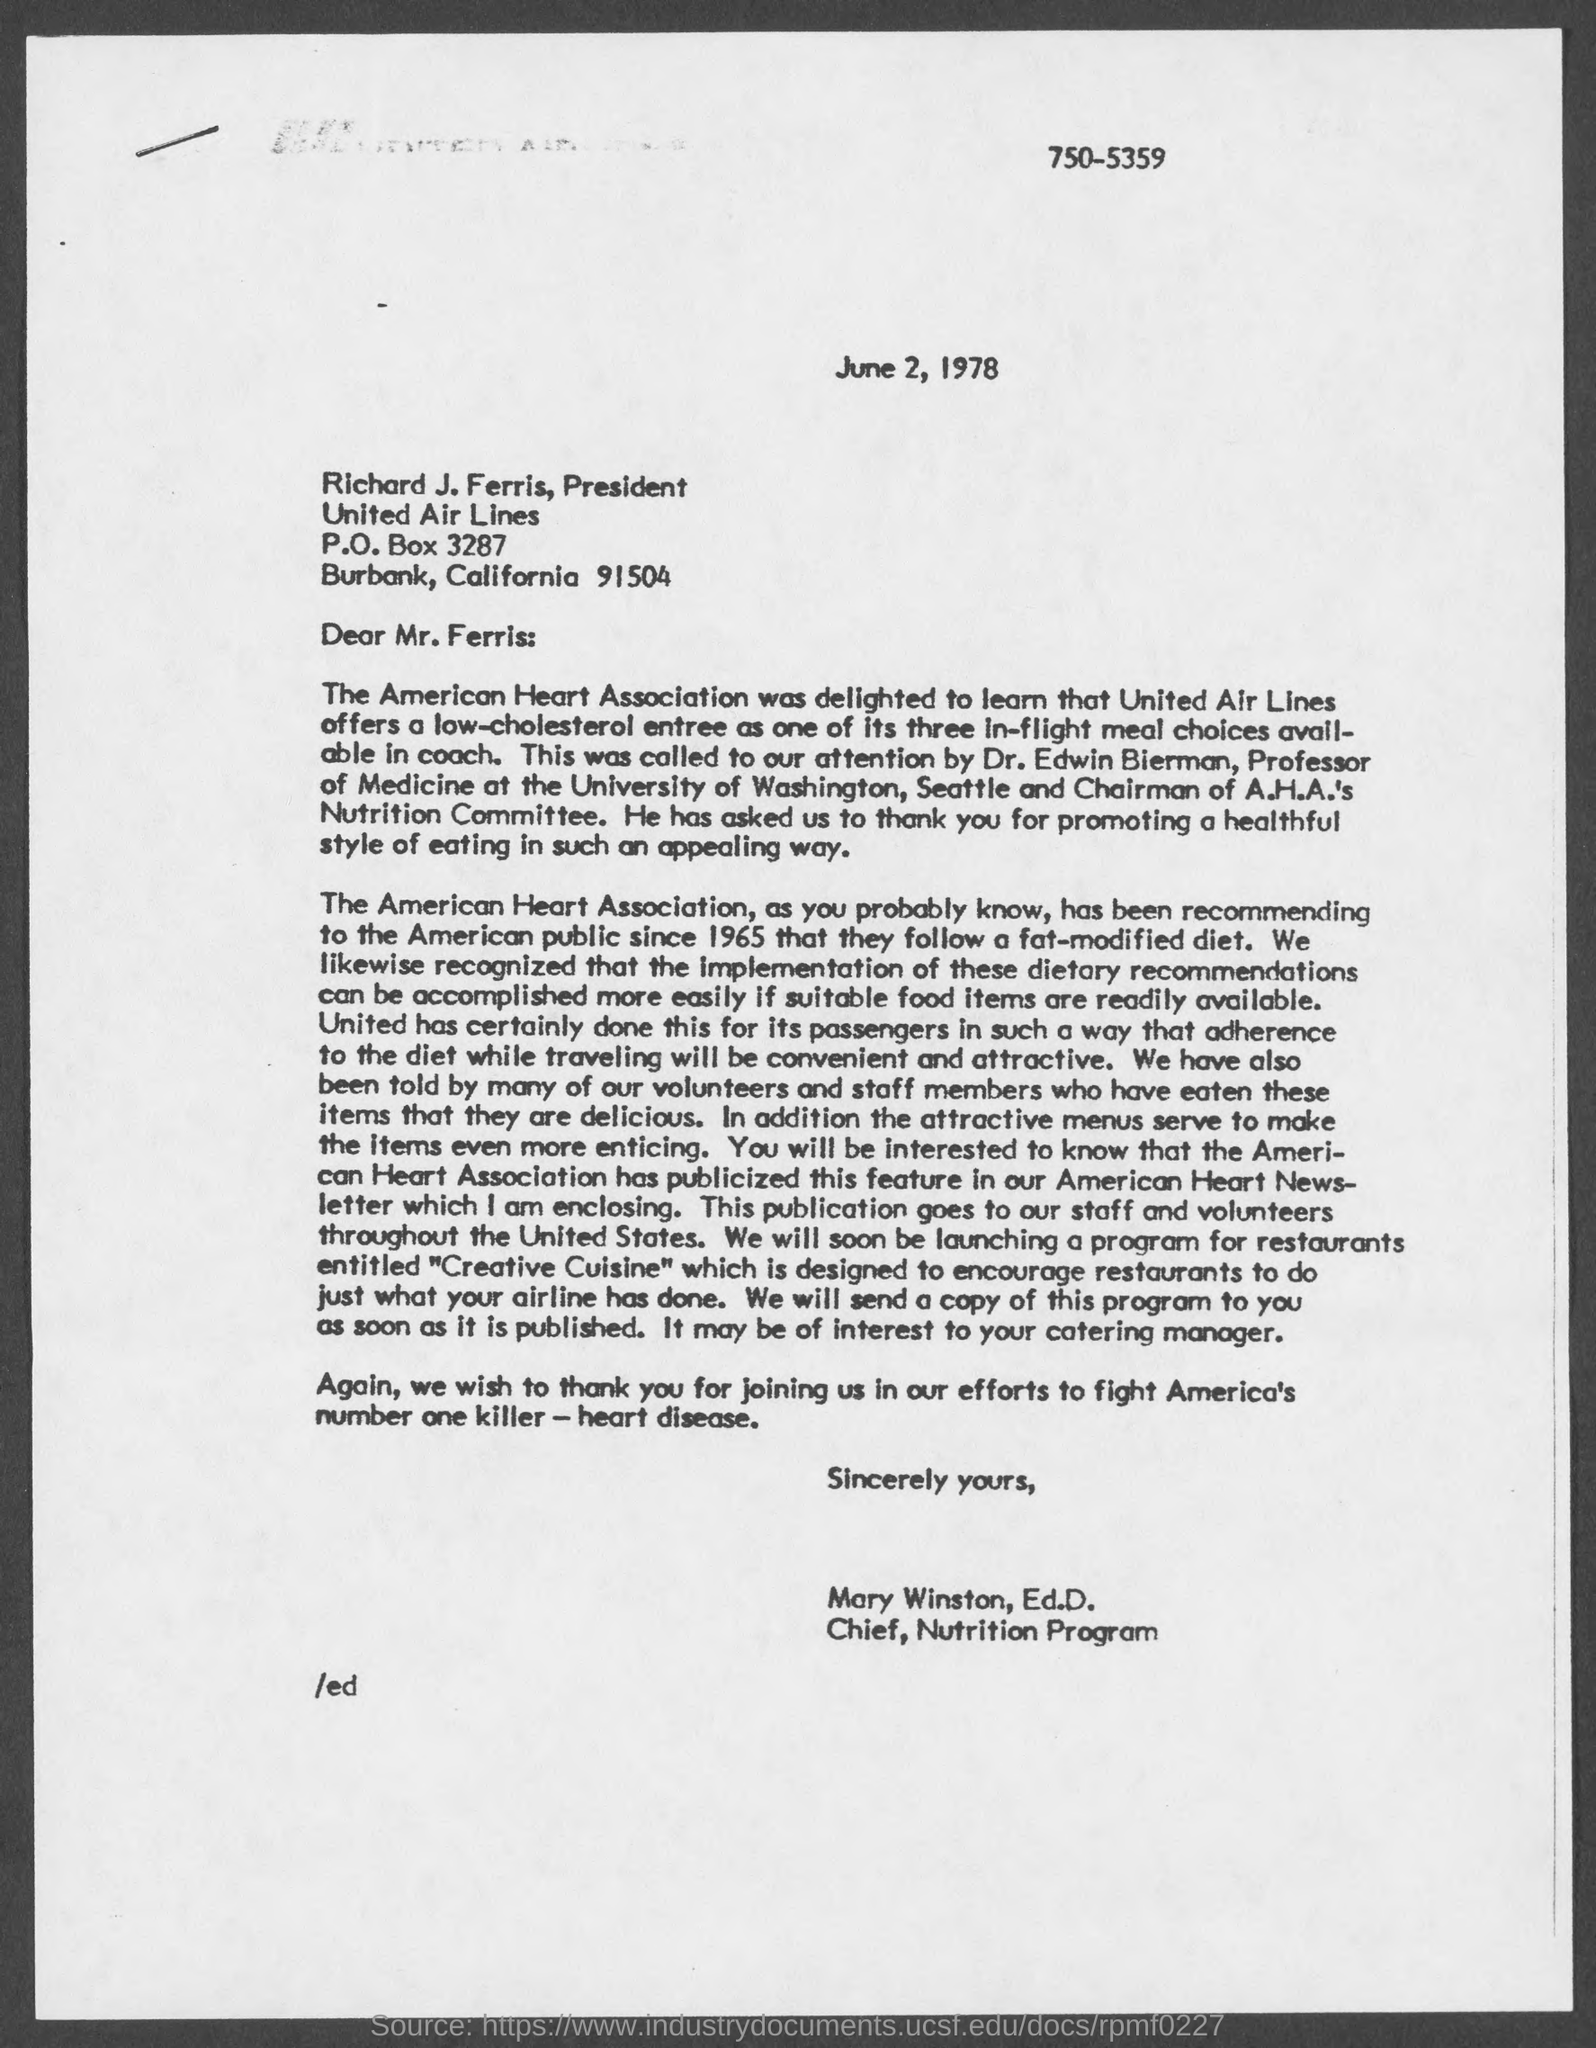Identify some key points in this picture. The date mentioned in this letter is June 2, 1978. The Chairman of A.H.A.'s Nutrition Committee is Dr. Edwin Bierman. 